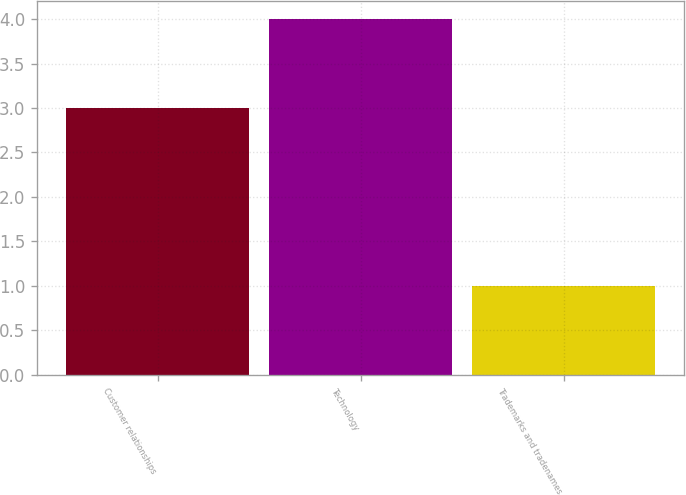<chart> <loc_0><loc_0><loc_500><loc_500><bar_chart><fcel>Customer relationships<fcel>Technology<fcel>Trademarks and tradenames<nl><fcel>3<fcel>4<fcel>1<nl></chart> 